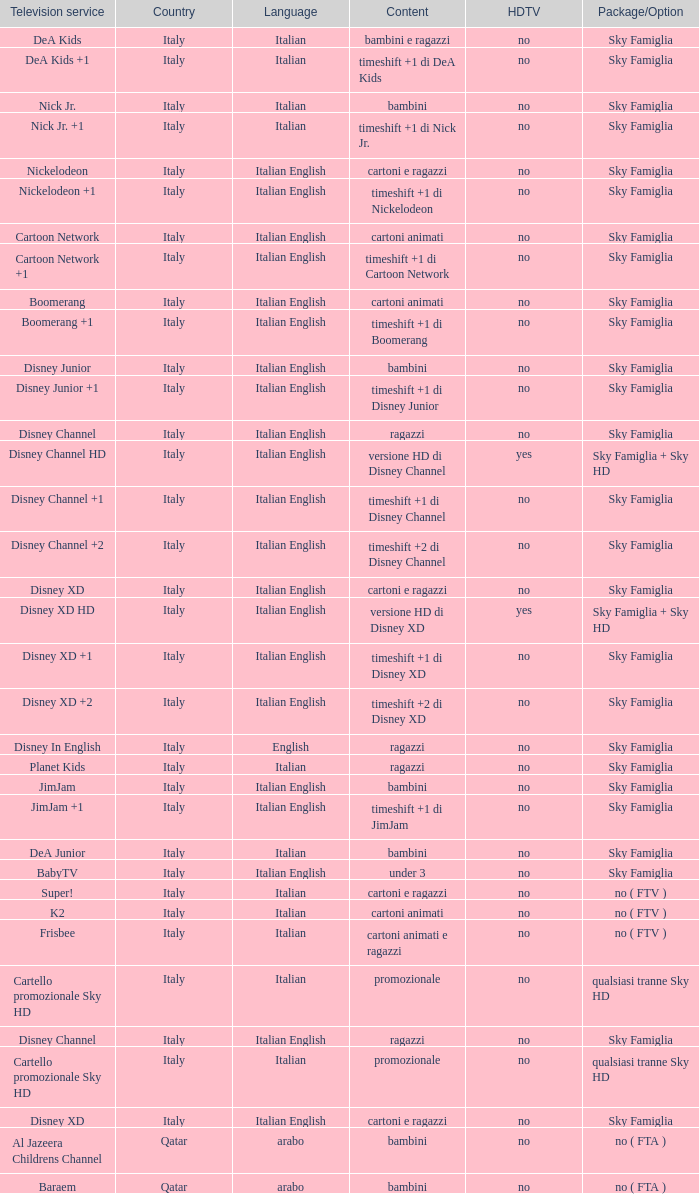What is the HDTV when the Package/Option is sky famiglia, and a Television service of boomerang +1? No. 